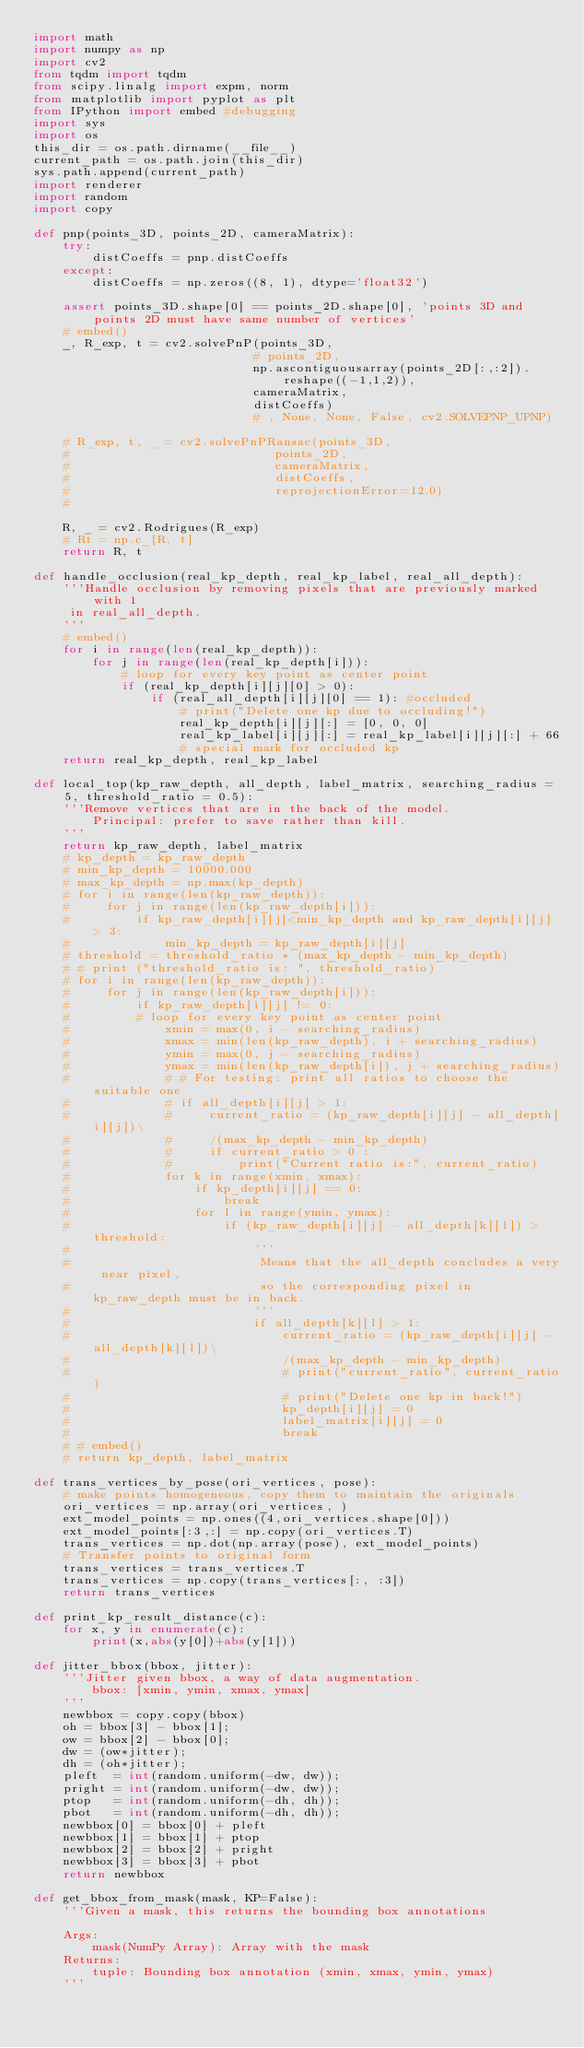<code> <loc_0><loc_0><loc_500><loc_500><_Python_>import math
import numpy as np
import cv2
from tqdm import tqdm
from scipy.linalg import expm, norm
from matplotlib import pyplot as plt
from IPython import embed #debugging
import sys
import os
this_dir = os.path.dirname(__file__)
current_path = os.path.join(this_dir)
sys.path.append(current_path)
import renderer
import random
import copy

def pnp(points_3D, points_2D, cameraMatrix):
    try:
        distCoeffs = pnp.distCoeffs
    except:
        distCoeffs = np.zeros((8, 1), dtype='float32')

    assert points_3D.shape[0] == points_2D.shape[0], 'points 3D and points 2D must have same number of vertices'
    # embed()
    _, R_exp, t = cv2.solvePnP(points_3D,
                              # points_2D,
                              np.ascontiguousarray(points_2D[:,:2]).reshape((-1,1,2)),
                              cameraMatrix,
                              distCoeffs)
                              # , None, None, False, cv2.SOLVEPNP_UPNP)
                                
    # R_exp, t, _ = cv2.solvePnPRansac(points_3D,
    #                            points_2D,
    #                            cameraMatrix,
    #                            distCoeffs,
    #                            reprojectionError=12.0)
    # 

    R, _ = cv2.Rodrigues(R_exp)
    # Rt = np.c_[R, t]
    return R, t

def handle_occlusion(real_kp_depth, real_kp_label, real_all_depth):
    '''Handle occlusion by removing pixels that are previously marked with 1
     in real_all_depth.
    '''
    # embed()
    for i in range(len(real_kp_depth)):
        for j in range(len(real_kp_depth[i])):
            # loop for every key point as center point
            if (real_kp_depth[i][j][0] > 0):
                if (real_all_depth[i][j][0] == 1): #occluded
                    # print("Delete one kp due to occluding!")
                    real_kp_depth[i][j][:] = [0, 0, 0]
                    real_kp_label[i][j][:] = real_kp_label[i][j][:] + 66
                    # special mark for occluded kp
    return real_kp_depth, real_kp_label

def local_top(kp_raw_depth, all_depth, label_matrix, searching_radius = 5, threshold_ratio = 0.5):
    '''Remove vertices that are in the back of the model.
        Principal: prefer to save rather than kill.
    '''
    return kp_raw_depth, label_matrix
    # kp_depth = kp_raw_depth
    # min_kp_depth = 10000.000
    # max_kp_depth = np.max(kp_depth)
    # for i in range(len(kp_raw_depth)):
    #     for j in range(len(kp_raw_depth[i])):
    #         if kp_raw_depth[i][j]<min_kp_depth and kp_raw_depth[i][j] > 3:
    #             min_kp_depth = kp_raw_depth[i][j]
    # threshold = threshold_ratio * (max_kp_depth - min_kp_depth)
    # # print ("threshold_ratio is: ", threshold_ratio)
    # for i in range(len(kp_raw_depth)):
    #     for j in range(len(kp_raw_depth[i])):
    #         if kp_raw_depth[i][j] != 0:
    #         # loop for every key point as center point
    #             xmin = max(0, i - searching_radius)
    #             xmax = min(len(kp_raw_depth), i + searching_radius)
    #             ymin = max(0, j - searching_radius)
    #             ymax = min(len(kp_raw_depth[i]), j + searching_radius)
    #             # # For testing: print all ratios to choose the suitable one
    #             # if all_depth[i][j] > 1:
    #             #     current_ratio = (kp_raw_depth[i][j] - all_depth[i][j])\
    #             #     /(max_kp_depth - min_kp_depth)
    #             #     if current_ratio > 0 :
    #             #         print("Current ratio is:", current_ratio)
    #             for k in range(xmin, xmax):
    #                 if kp_depth[i][j] == 0:
    #                     break
    #                 for l in range(ymin, ymax):
    #                     if (kp_raw_depth[i][j] - all_depth[k][l]) > threshold:
    #                         '''
    #                          Means that the all_depth concludes a very near pixel,
    #                          so the corresponding pixel in kp_raw_depth must be in back.
    #                         '''
    #                         if all_depth[k][l] > 1:
    #                             current_ratio = (kp_raw_depth[i][j] - all_depth[k][l])\
    #                             /(max_kp_depth - min_kp_depth)
    #                             # print("current_ratio", current_ratio)
    #                             # print("Delete one kp in back!")
    #                             kp_depth[i][j] = 0
    #                             label_matrix[i][j] = 0
    #                             break
    # # embed()
    # return kp_depth, label_matrix

def trans_vertices_by_pose(ori_vertices, pose):
    # make points homogeneous, copy them to maintain the originals
    ori_vertices = np.array(ori_vertices, )
    ext_model_points = np.ones((4,ori_vertices.shape[0]))
    ext_model_points[:3,:] = np.copy(ori_vertices.T)
    trans_vertices = np.dot(np.array(pose), ext_model_points)
    # Transfer points to original form
    trans_vertices = trans_vertices.T
    trans_vertices = np.copy(trans_vertices[:, :3])
    return trans_vertices

def print_kp_result_distance(c):
    for x, y in enumerate(c):
        print(x,abs(y[0])+abs(y[1]))

def jitter_bbox(bbox, jitter):
    '''Jitter given bbox, a way of data augmentation.
        bbox: [xmin, ymin, xmax, ymax]
    '''
    newbbox = copy.copy(bbox)
    oh = bbox[3] - bbox[1];
    ow = bbox[2] - bbox[0];
    dw = (ow*jitter);
    dh = (oh*jitter);
    pleft  = int(random.uniform(-dw, dw));
    pright = int(random.uniform(-dw, dw));
    ptop   = int(random.uniform(-dh, dh));
    pbot   = int(random.uniform(-dh, dh));
    newbbox[0] = bbox[0] + pleft
    newbbox[1] = bbox[1] + ptop
    newbbox[2] = bbox[2] + pright
    newbbox[3] = bbox[3] + pbot
    return newbbox

def get_bbox_from_mask(mask, KP=False):
    '''Given a mask, this returns the bounding box annotations

    Args:
        mask(NumPy Array): Array with the mask
    Returns:
        tuple: Bounding box annotation (xmin, xmax, ymin, ymax)
    '''</code> 